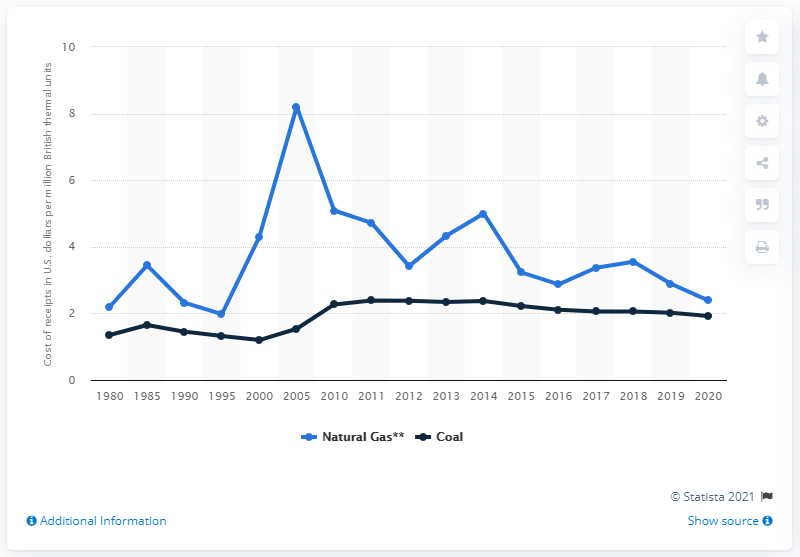Highlight a few significant elements in this photo. In 2020, the cost per million British thermal unit (mmBtu) of natural gas for coal power plant operators was $1.92. In 2020, electricity producers paid an average of 2.39 US dollars per million British thermal units for natural gas. 